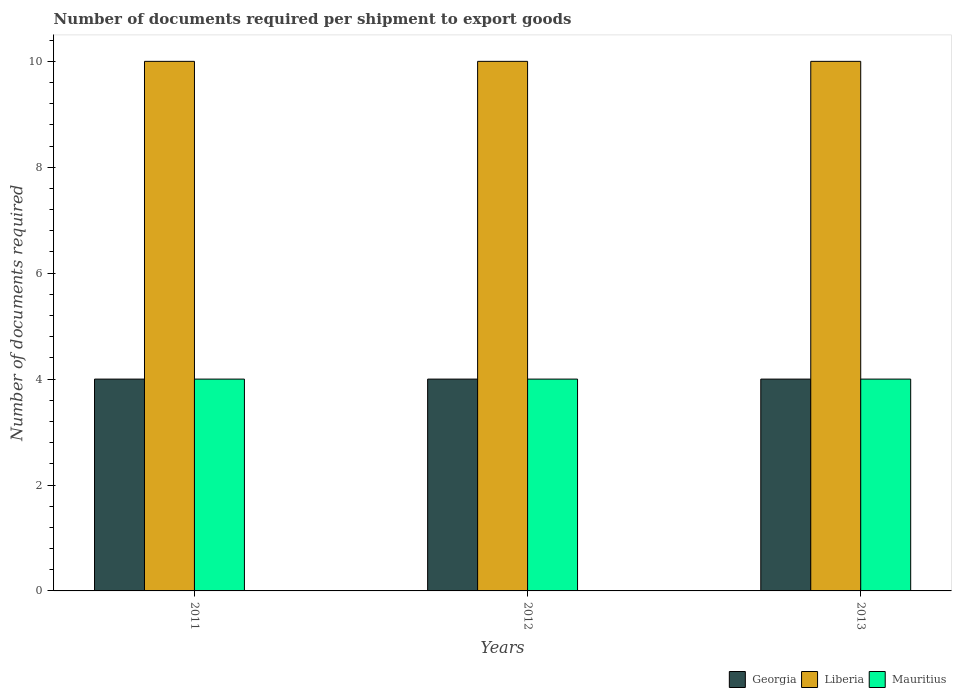How many different coloured bars are there?
Offer a very short reply. 3. Are the number of bars on each tick of the X-axis equal?
Your response must be concise. Yes. How many bars are there on the 2nd tick from the left?
Keep it short and to the point. 3. How many bars are there on the 3rd tick from the right?
Offer a terse response. 3. What is the label of the 2nd group of bars from the left?
Your response must be concise. 2012. In how many cases, is the number of bars for a given year not equal to the number of legend labels?
Give a very brief answer. 0. Across all years, what is the maximum number of documents required per shipment to export goods in Georgia?
Provide a succinct answer. 4. Across all years, what is the minimum number of documents required per shipment to export goods in Mauritius?
Make the answer very short. 4. What is the total number of documents required per shipment to export goods in Mauritius in the graph?
Your answer should be compact. 12. What is the average number of documents required per shipment to export goods in Mauritius per year?
Offer a very short reply. 4. In how many years, is the number of documents required per shipment to export goods in Liberia greater than 3.2?
Your response must be concise. 3. What is the ratio of the number of documents required per shipment to export goods in Mauritius in 2012 to that in 2013?
Offer a very short reply. 1. Is the difference between the number of documents required per shipment to export goods in Mauritius in 2011 and 2013 greater than the difference between the number of documents required per shipment to export goods in Liberia in 2011 and 2013?
Your answer should be compact. No. What is the difference between the highest and the lowest number of documents required per shipment to export goods in Liberia?
Make the answer very short. 0. In how many years, is the number of documents required per shipment to export goods in Georgia greater than the average number of documents required per shipment to export goods in Georgia taken over all years?
Your response must be concise. 0. What does the 2nd bar from the left in 2011 represents?
Make the answer very short. Liberia. What does the 3rd bar from the right in 2012 represents?
Provide a succinct answer. Georgia. How many bars are there?
Keep it short and to the point. 9. Are all the bars in the graph horizontal?
Offer a very short reply. No. Does the graph contain grids?
Provide a succinct answer. No. Where does the legend appear in the graph?
Offer a very short reply. Bottom right. How are the legend labels stacked?
Ensure brevity in your answer.  Horizontal. What is the title of the graph?
Make the answer very short. Number of documents required per shipment to export goods. Does "Iraq" appear as one of the legend labels in the graph?
Your answer should be very brief. No. What is the label or title of the X-axis?
Give a very brief answer. Years. What is the label or title of the Y-axis?
Give a very brief answer. Number of documents required. What is the Number of documents required of Georgia in 2011?
Your answer should be very brief. 4. What is the Number of documents required of Liberia in 2011?
Ensure brevity in your answer.  10. What is the Number of documents required in Liberia in 2012?
Your response must be concise. 10. What is the Number of documents required of Mauritius in 2012?
Provide a short and direct response. 4. What is the Number of documents required in Liberia in 2013?
Your response must be concise. 10. Across all years, what is the maximum Number of documents required of Mauritius?
Provide a succinct answer. 4. Across all years, what is the minimum Number of documents required of Georgia?
Your response must be concise. 4. Across all years, what is the minimum Number of documents required in Liberia?
Provide a succinct answer. 10. Across all years, what is the minimum Number of documents required of Mauritius?
Offer a very short reply. 4. What is the difference between the Number of documents required of Liberia in 2011 and that in 2012?
Offer a very short reply. 0. What is the difference between the Number of documents required of Georgia in 2011 and that in 2013?
Keep it short and to the point. 0. What is the difference between the Number of documents required in Liberia in 2011 and that in 2013?
Offer a terse response. 0. What is the difference between the Number of documents required in Mauritius in 2011 and that in 2013?
Keep it short and to the point. 0. What is the difference between the Number of documents required in Georgia in 2011 and the Number of documents required in Liberia in 2012?
Your answer should be compact. -6. What is the difference between the Number of documents required in Georgia in 2011 and the Number of documents required in Mauritius in 2012?
Your response must be concise. 0. What is the difference between the Number of documents required in Georgia in 2012 and the Number of documents required in Liberia in 2013?
Your answer should be very brief. -6. What is the average Number of documents required in Mauritius per year?
Provide a succinct answer. 4. In the year 2011, what is the difference between the Number of documents required of Georgia and Number of documents required of Liberia?
Offer a very short reply. -6. In the year 2011, what is the difference between the Number of documents required of Georgia and Number of documents required of Mauritius?
Your answer should be very brief. 0. In the year 2011, what is the difference between the Number of documents required in Liberia and Number of documents required in Mauritius?
Offer a very short reply. 6. In the year 2012, what is the difference between the Number of documents required in Liberia and Number of documents required in Mauritius?
Offer a very short reply. 6. In the year 2013, what is the difference between the Number of documents required in Georgia and Number of documents required in Liberia?
Your answer should be compact. -6. In the year 2013, what is the difference between the Number of documents required of Georgia and Number of documents required of Mauritius?
Offer a very short reply. 0. In the year 2013, what is the difference between the Number of documents required of Liberia and Number of documents required of Mauritius?
Give a very brief answer. 6. What is the ratio of the Number of documents required of Georgia in 2011 to that in 2012?
Your answer should be very brief. 1. What is the ratio of the Number of documents required of Liberia in 2011 to that in 2012?
Make the answer very short. 1. What is the ratio of the Number of documents required of Mauritius in 2011 to that in 2013?
Give a very brief answer. 1. What is the ratio of the Number of documents required in Georgia in 2012 to that in 2013?
Make the answer very short. 1. What is the ratio of the Number of documents required in Mauritius in 2012 to that in 2013?
Offer a very short reply. 1. What is the difference between the highest and the lowest Number of documents required of Georgia?
Offer a very short reply. 0. What is the difference between the highest and the lowest Number of documents required in Mauritius?
Your answer should be very brief. 0. 